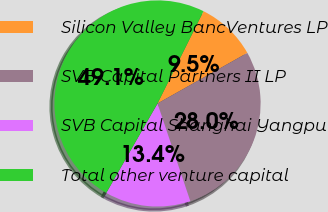<chart> <loc_0><loc_0><loc_500><loc_500><pie_chart><fcel>Silicon Valley BancVentures LP<fcel>SVB Capital Partners II LP<fcel>SVB Capital Shanghai Yangpu<fcel>Total other venture capital<nl><fcel>9.48%<fcel>28.0%<fcel>13.44%<fcel>49.08%<nl></chart> 